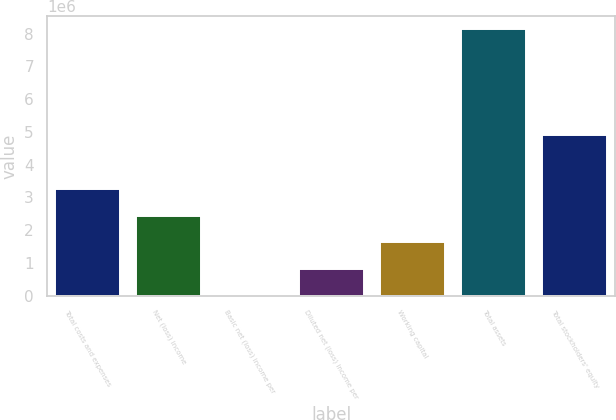<chart> <loc_0><loc_0><loc_500><loc_500><bar_chart><fcel>Total costs and expenses<fcel>Net (loss) income<fcel>Basic net (loss) income per<fcel>Diluted net (loss) income per<fcel>Working capital<fcel>Total assets<fcel>Total stockholders' equity<nl><fcel>3.25073e+06<fcel>2.43804e+06<fcel>1.69<fcel>812683<fcel>1.62536e+06<fcel>8.12681e+06<fcel>4.89594e+06<nl></chart> 